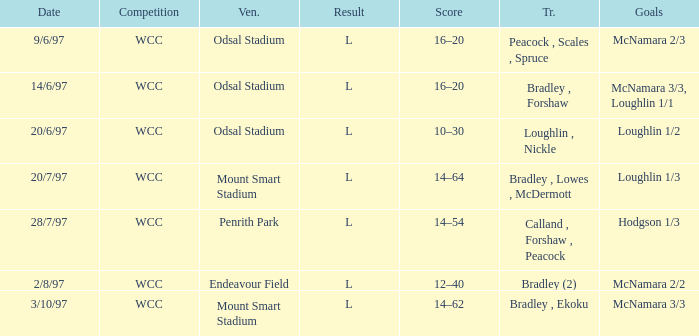Help me parse the entirety of this table. {'header': ['Date', 'Competition', 'Ven.', 'Result', 'Score', 'Tr.', 'Goals'], 'rows': [['9/6/97', 'WCC', 'Odsal Stadium', 'L', '16–20', 'Peacock , Scales , Spruce', 'McNamara 2/3'], ['14/6/97', 'WCC', 'Odsal Stadium', 'L', '16–20', 'Bradley , Forshaw', 'McNamara 3/3, Loughlin 1/1'], ['20/6/97', 'WCC', 'Odsal Stadium', 'L', '10–30', 'Loughlin , Nickle', 'Loughlin 1/2'], ['20/7/97', 'WCC', 'Mount Smart Stadium', 'L', '14–64', 'Bradley , Lowes , McDermott', 'Loughlin 1/3'], ['28/7/97', 'WCC', 'Penrith Park', 'L', '14–54', 'Calland , Forshaw , Peacock', 'Hodgson 1/3'], ['2/8/97', 'WCC', 'Endeavour Field', 'L', '12–40', 'Bradley (2)', 'McNamara 2/2'], ['3/10/97', 'WCC', 'Mount Smart Stadium', 'L', '14–62', 'Bradley , Ekoku', 'McNamara 3/3']]} What were the tries on 14/6/97? Bradley , Forshaw. 